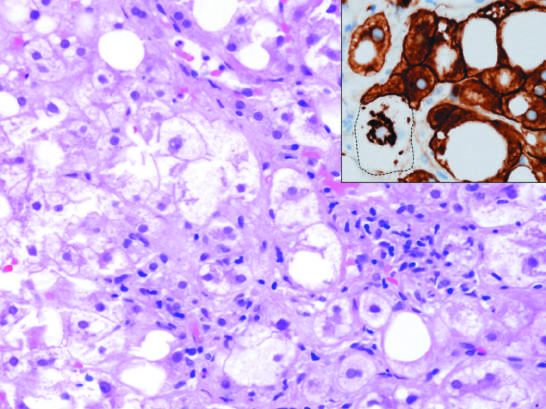s the fibrous capsule associated with chronic alcohol use?
Answer the question using a single word or phrase. No 